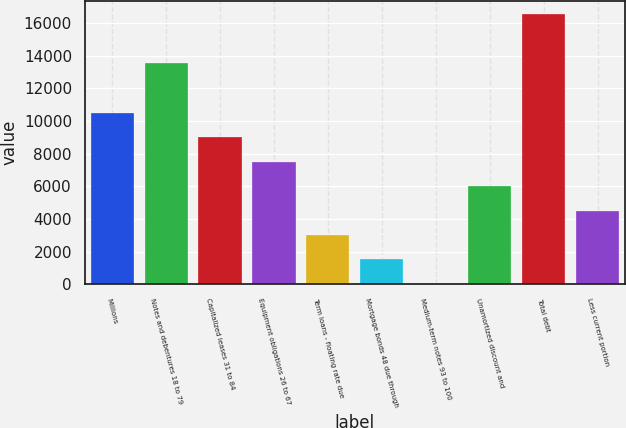<chart> <loc_0><loc_0><loc_500><loc_500><bar_chart><fcel>Millions<fcel>Notes and debentures 18 to 79<fcel>Capitalized leases 31 to 84<fcel>Equipment obligations 26 to 67<fcel>Term loans - floating rate due<fcel>Mortgage bonds 48 due through<fcel>Medium-term notes 93 to 100<fcel>Unamortized discount and<fcel>Total debt<fcel>Less current portion<nl><fcel>10511.8<fcel>13547<fcel>9013.4<fcel>7515<fcel>3019.8<fcel>1521.4<fcel>23<fcel>6016.6<fcel>16543.8<fcel>4518.2<nl></chart> 